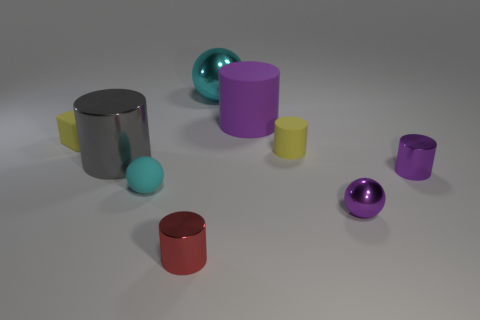Add 1 large rubber objects. How many objects exist? 10 Subtract all tiny yellow rubber cylinders. How many cylinders are left? 4 Subtract all cubes. How many objects are left? 8 Subtract 1 cylinders. How many cylinders are left? 4 Subtract all purple balls. Subtract all blue cylinders. How many balls are left? 2 Subtract all blue spheres. How many gray cylinders are left? 1 Subtract all tiny cyan cubes. Subtract all small yellow things. How many objects are left? 7 Add 4 red cylinders. How many red cylinders are left? 5 Add 2 small purple metallic spheres. How many small purple metallic spheres exist? 3 Subtract all yellow cylinders. How many cylinders are left? 4 